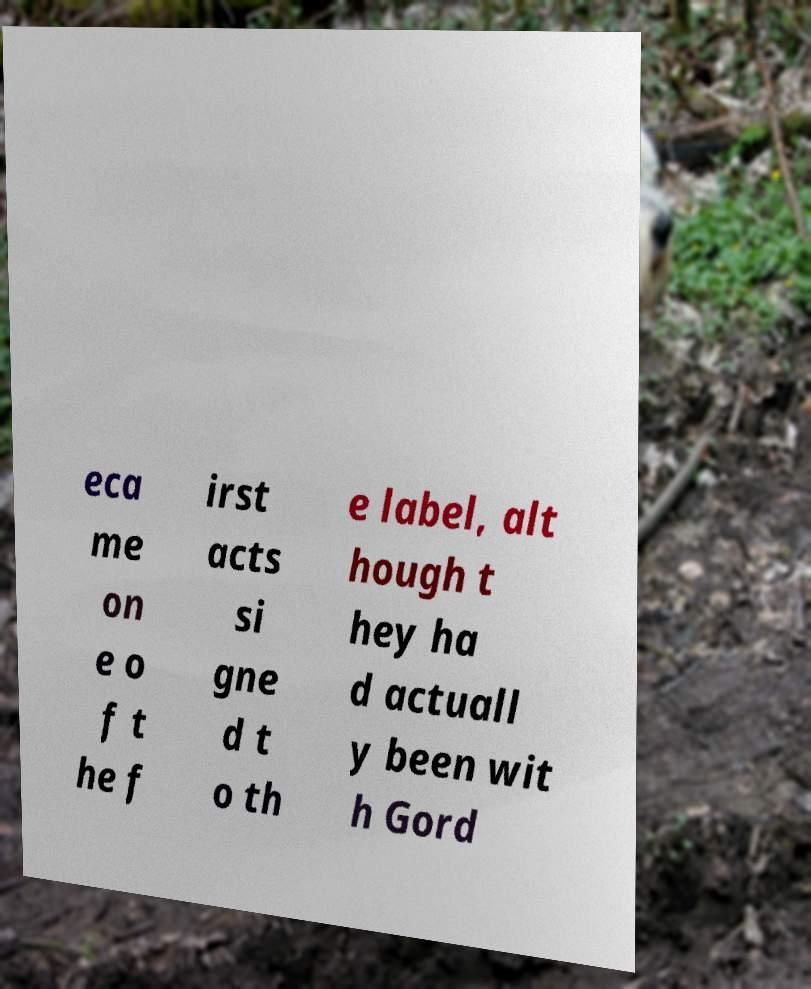Please read and relay the text visible in this image. What does it say? eca me on e o f t he f irst acts si gne d t o th e label, alt hough t hey ha d actuall y been wit h Gord 